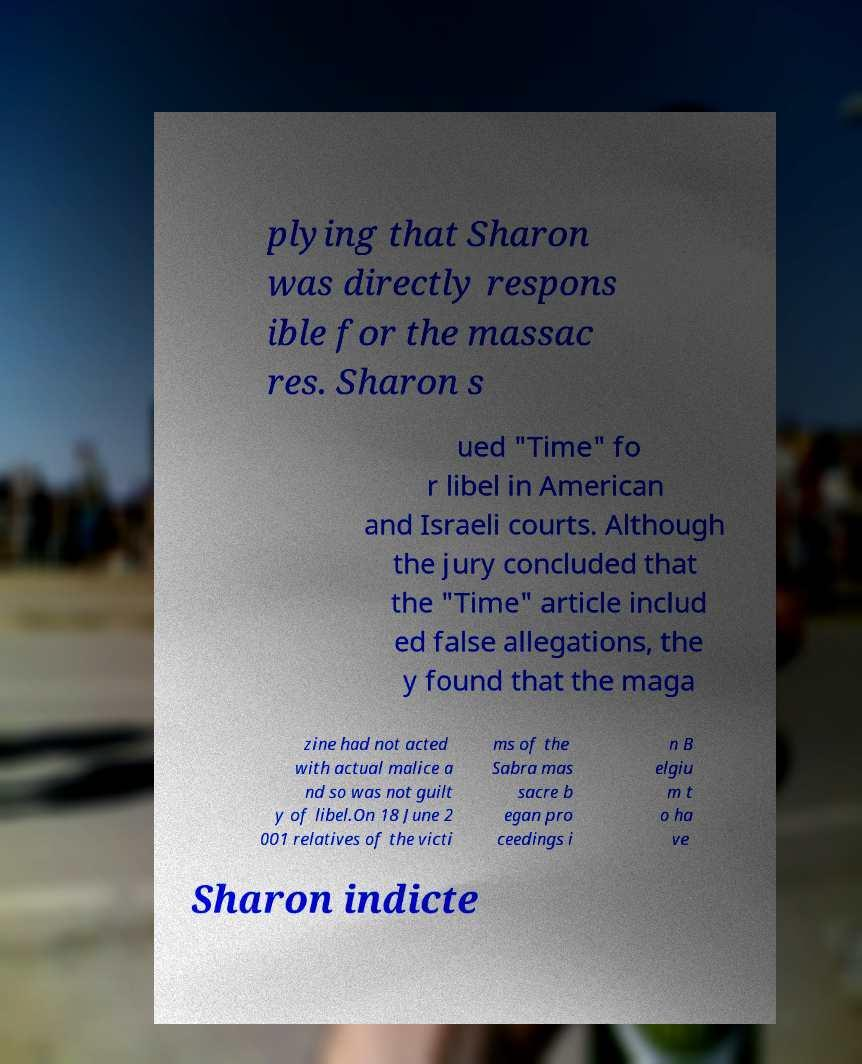Please read and relay the text visible in this image. What does it say? plying that Sharon was directly respons ible for the massac res. Sharon s ued "Time" fo r libel in American and Israeli courts. Although the jury concluded that the "Time" article includ ed false allegations, the y found that the maga zine had not acted with actual malice a nd so was not guilt y of libel.On 18 June 2 001 relatives of the victi ms of the Sabra mas sacre b egan pro ceedings i n B elgiu m t o ha ve Sharon indicte 